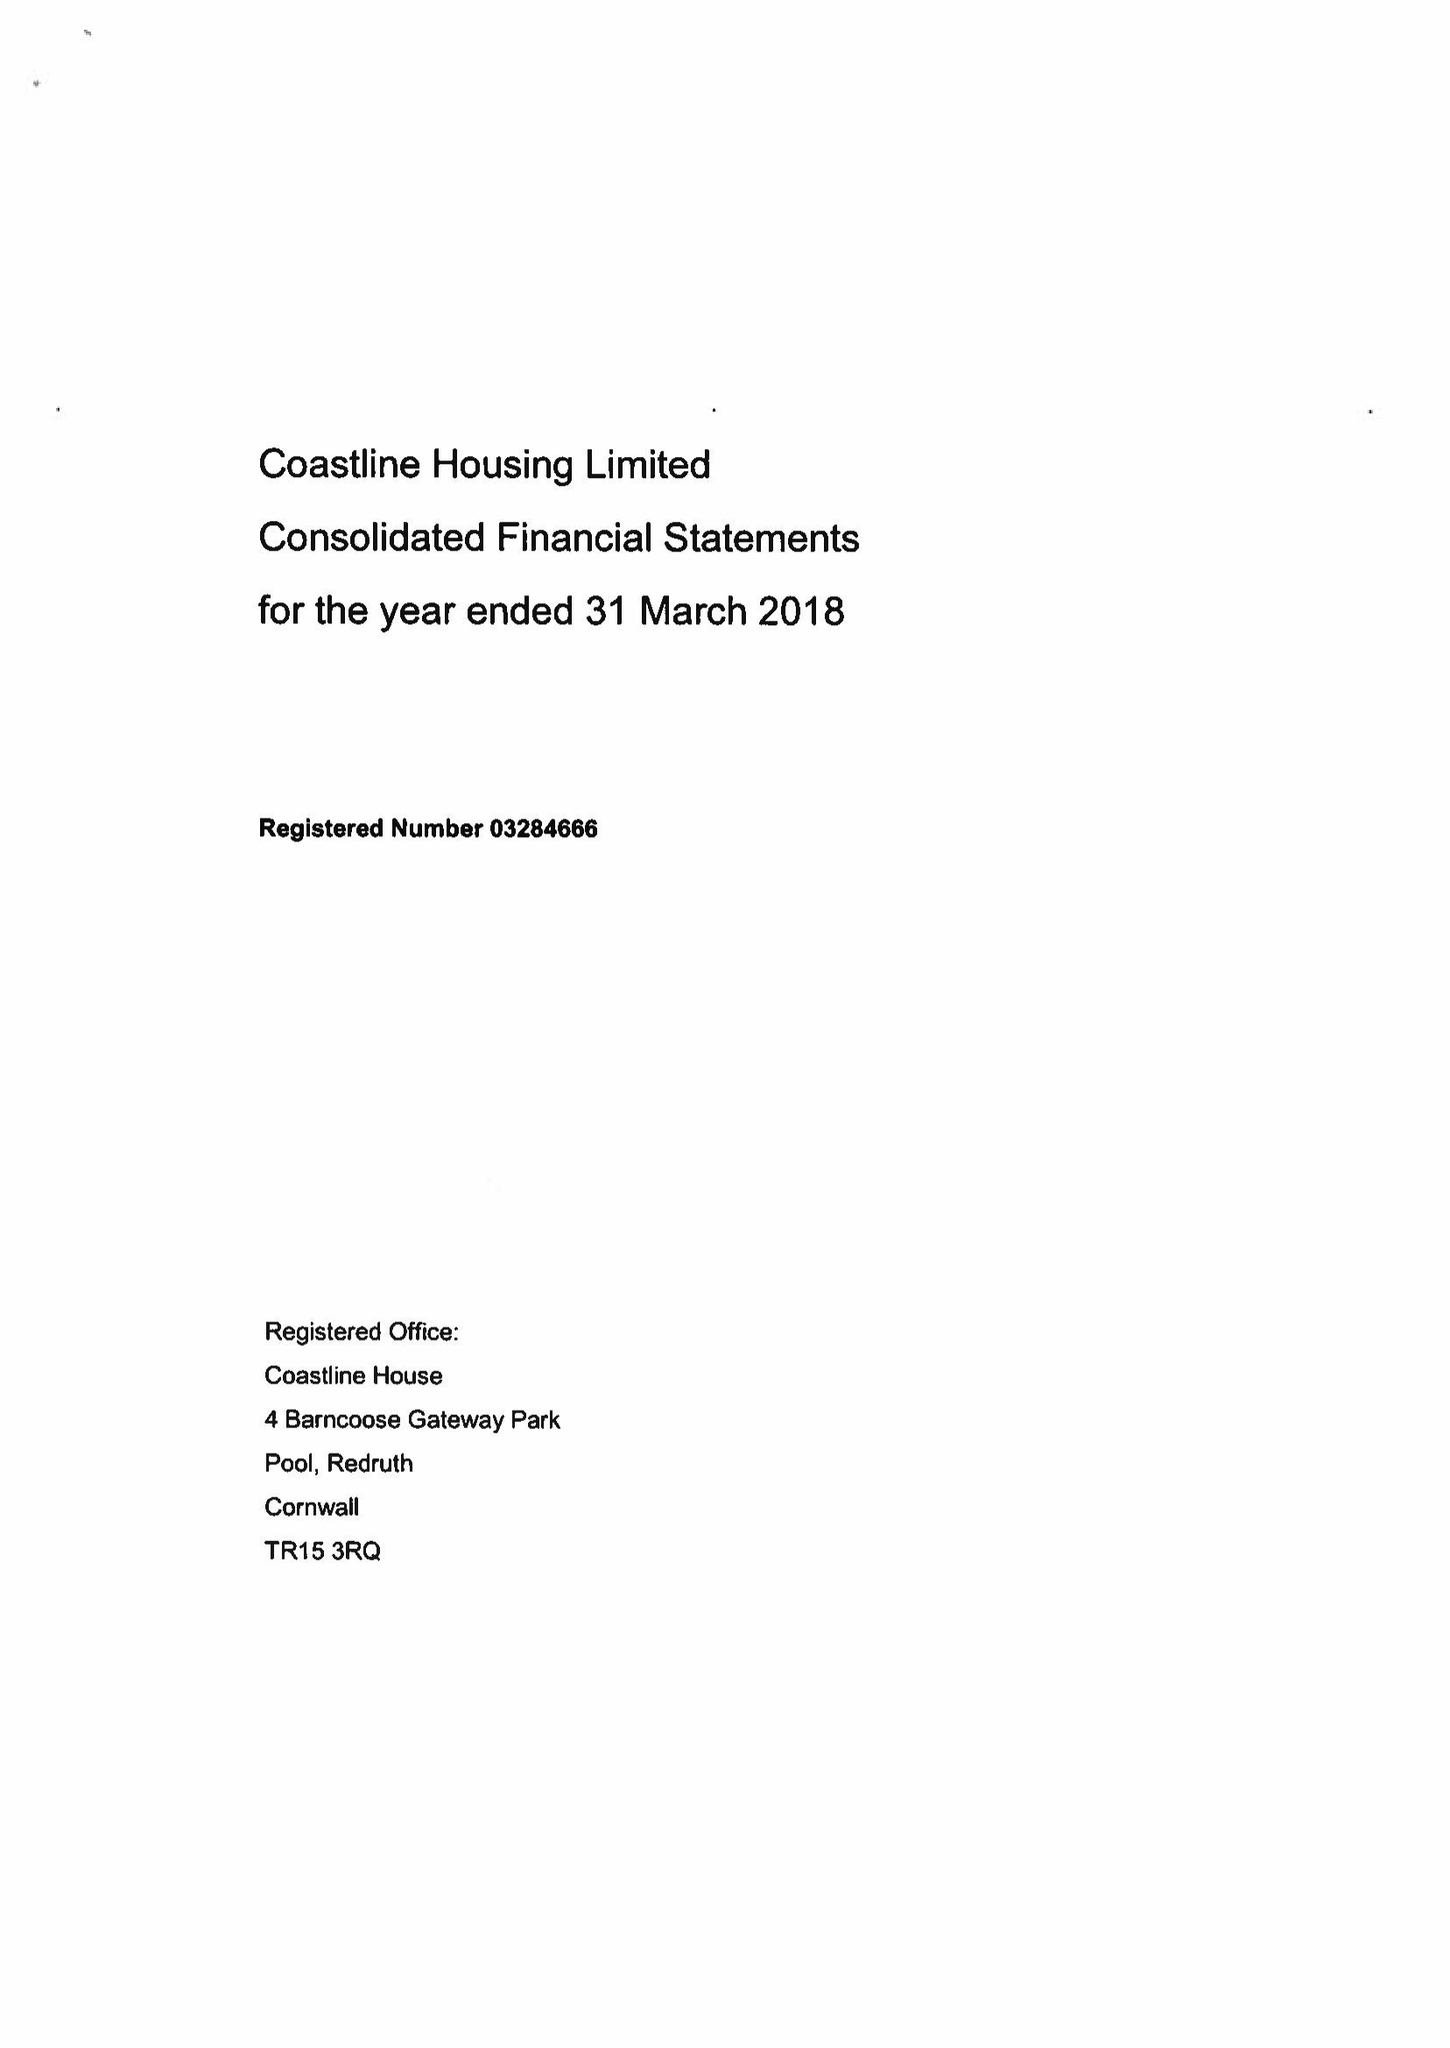What is the value for the address__post_town?
Answer the question using a single word or phrase. REDRUTH 